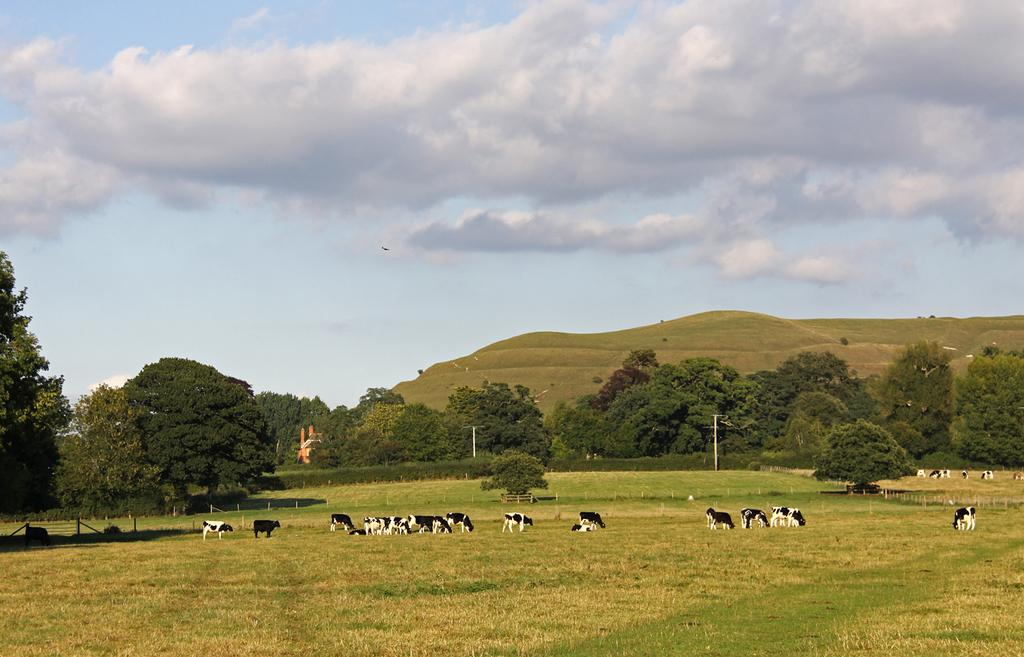What types of vegetation can be seen in the foreground of the image? There are trees and plants in the foreground of the image. What other elements can be seen in the foreground of the image? There are current polls, cattle, crops, and fencing in the foreground of the image. What geographical feature is visible in the middle of the image? There are hills in the middle of the image. What is visible at the top of the image? The sky is visible at the top of the image. What news is being discussed by the friends in the image? There are no friends present in the image, and therefore no discussion of news can be observed. Can you tell me how many basketballs are visible in the image? There are no basketballs present in the image. 